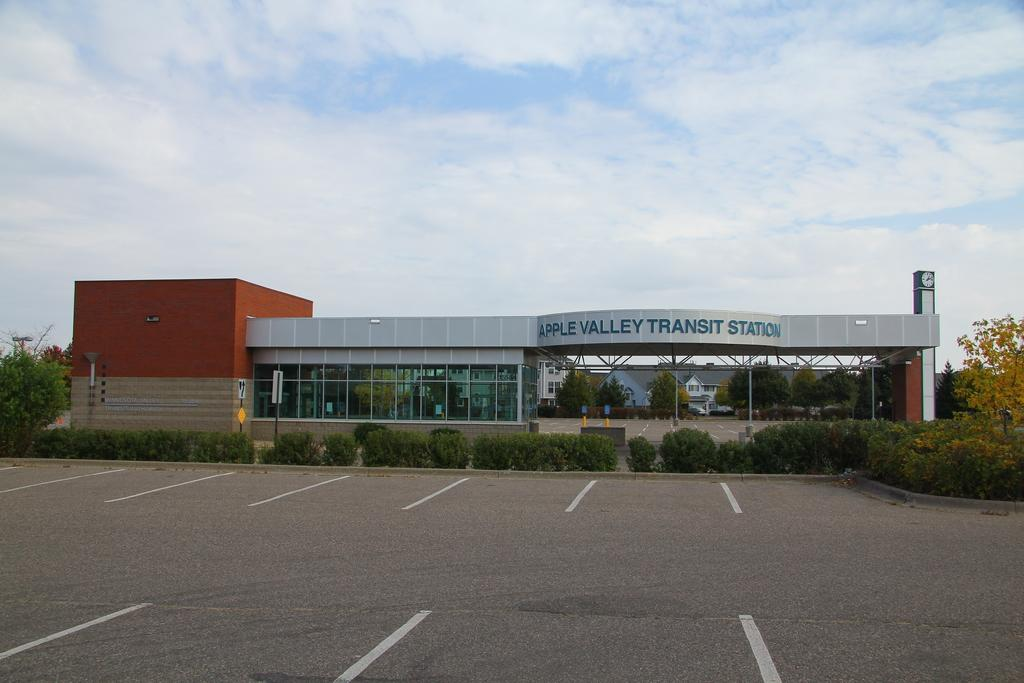<image>
Describe the image concisely. Apple Valley Transit Station sits behind an empty parking lot. 